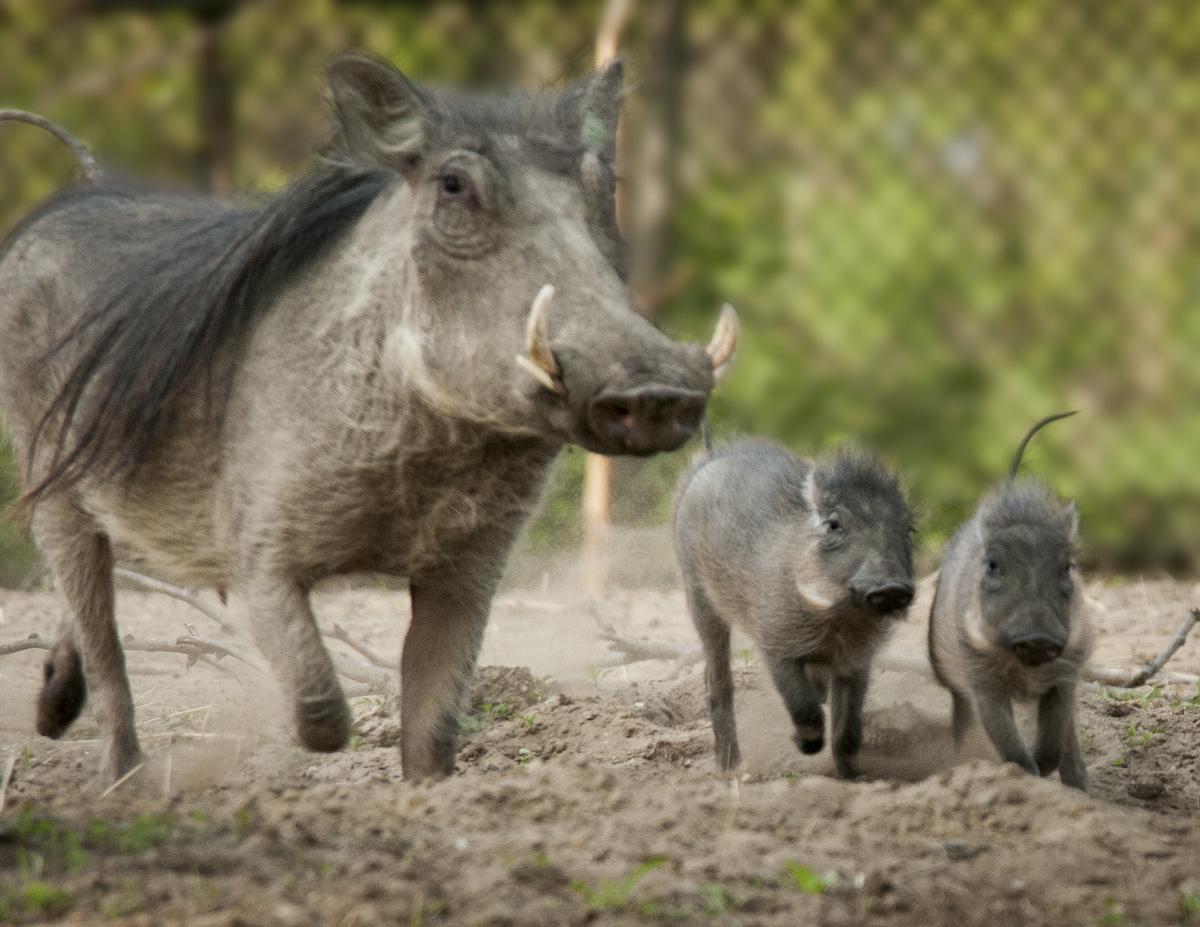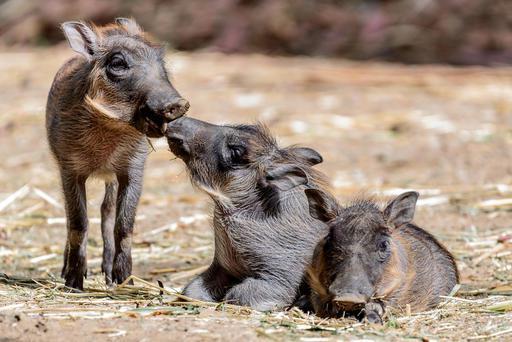The first image is the image on the left, the second image is the image on the right. Evaluate the accuracy of this statement regarding the images: "One of the animals is lying down on the ground.". Is it true? Answer yes or no. Yes. The first image is the image on the left, the second image is the image on the right. Evaluate the accuracy of this statement regarding the images: "Left and right images contain the same number of warthogs, and the combined images contain at least four warthogs.". Is it true? Answer yes or no. Yes. 